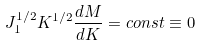<formula> <loc_0><loc_0><loc_500><loc_500>J _ { 1 } ^ { 1 / 2 } K ^ { 1 / 2 } \frac { d M } { d K } = c o n s t \equiv 0</formula> 